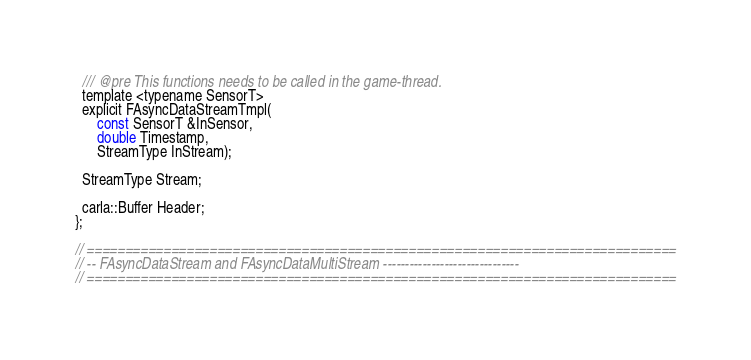Convert code to text. <code><loc_0><loc_0><loc_500><loc_500><_C_>
  /// @pre This functions needs to be called in the game-thread.
  template <typename SensorT>
  explicit FAsyncDataStreamTmpl(
      const SensorT &InSensor,
      double Timestamp,
      StreamType InStream);

  StreamType Stream;

  carla::Buffer Header;
};

// =============================================================================
// -- FAsyncDataStream and FAsyncDataMultiStream -------------------------------
// =============================================================================
</code> 